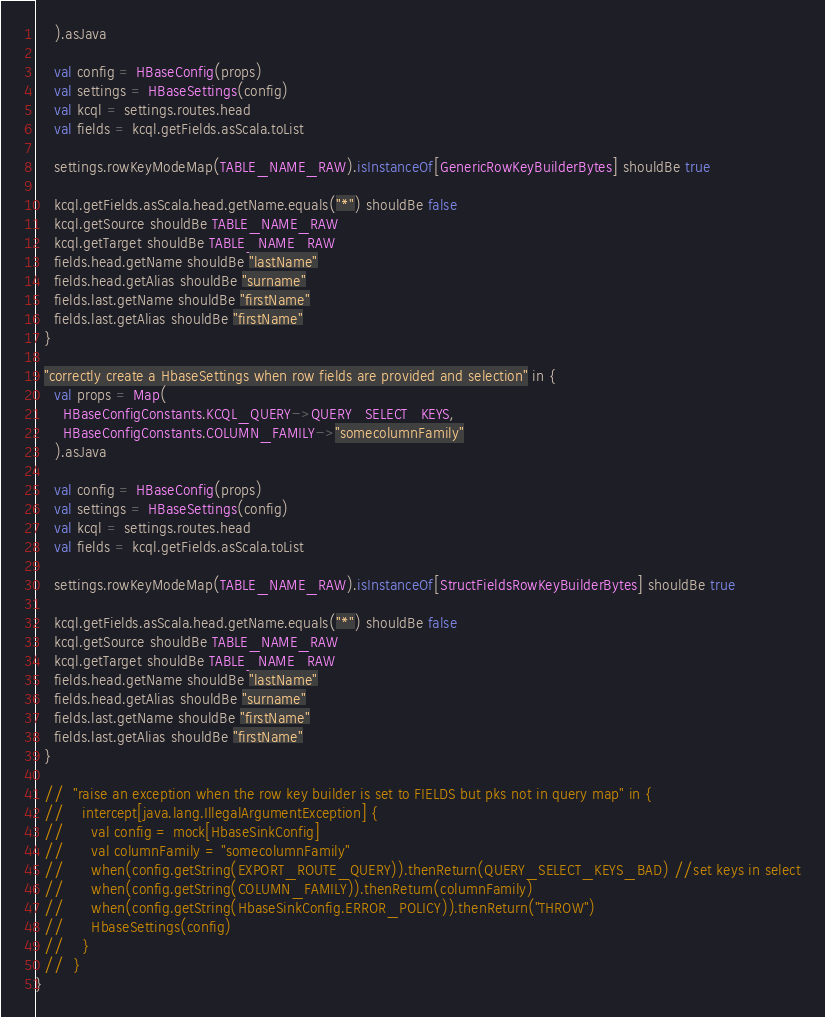<code> <loc_0><loc_0><loc_500><loc_500><_Scala_>    ).asJava

    val config = HBaseConfig(props)
    val settings = HBaseSettings(config)
    val kcql = settings.routes.head
    val fields = kcql.getFields.asScala.toList

    settings.rowKeyModeMap(TABLE_NAME_RAW).isInstanceOf[GenericRowKeyBuilderBytes] shouldBe true

    kcql.getFields.asScala.head.getName.equals("*") shouldBe false
    kcql.getSource shouldBe TABLE_NAME_RAW
    kcql.getTarget shouldBe TABLE_NAME_RAW
    fields.head.getName shouldBe "lastName"
    fields.head.getAlias shouldBe "surname"
    fields.last.getName shouldBe "firstName"
    fields.last.getAlias shouldBe "firstName"
  }

  "correctly create a HbaseSettings when row fields are provided and selection" in {
    val props = Map(
      HBaseConfigConstants.KCQL_QUERY->QUERY_SELECT_KEYS,
      HBaseConfigConstants.COLUMN_FAMILY->"somecolumnFamily"
    ).asJava

    val config = HBaseConfig(props)
    val settings = HBaseSettings(config)
    val kcql = settings.routes.head
    val fields = kcql.getFields.asScala.toList

    settings.rowKeyModeMap(TABLE_NAME_RAW).isInstanceOf[StructFieldsRowKeyBuilderBytes] shouldBe true

    kcql.getFields.asScala.head.getName.equals("*") shouldBe false
    kcql.getSource shouldBe TABLE_NAME_RAW
    kcql.getTarget shouldBe TABLE_NAME_RAW
    fields.head.getName shouldBe "lastName"
    fields.head.getAlias shouldBe "surname"
    fields.last.getName shouldBe "firstName"
    fields.last.getAlias shouldBe "firstName"
  }

  //  "raise an exception when the row key builder is set to FIELDS but pks not in query map" in {
  //    intercept[java.lang.IllegalArgumentException] {
  //      val config = mock[HbaseSinkConfig]
  //      val columnFamily = "somecolumnFamily"
  //      when(config.getString(EXPORT_ROUTE_QUERY)).thenReturn(QUERY_SELECT_KEYS_BAD) //set keys in select
  //      when(config.getString(COLUMN_FAMILY)).thenReturn(columnFamily)
  //      when(config.getString(HbaseSinkConfig.ERROR_POLICY)).thenReturn("THROW")
  //      HbaseSettings(config)
  //    }
  //  }
}
</code> 